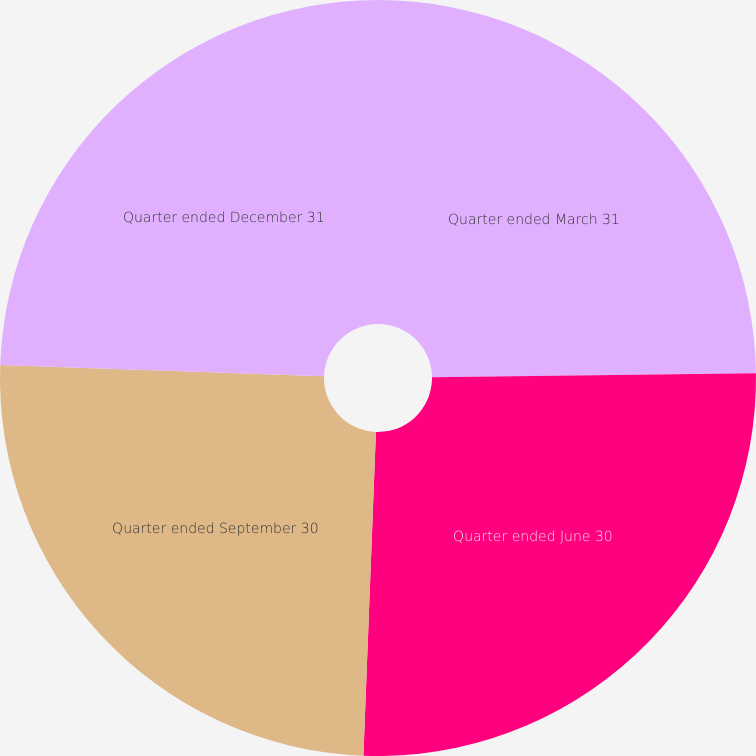Convert chart to OTSL. <chart><loc_0><loc_0><loc_500><loc_500><pie_chart><fcel>Quarter ended March 31<fcel>Quarter ended June 30<fcel>Quarter ended September 30<fcel>Quarter ended December 31<nl><fcel>24.8%<fcel>25.82%<fcel>24.94%<fcel>24.45%<nl></chart> 